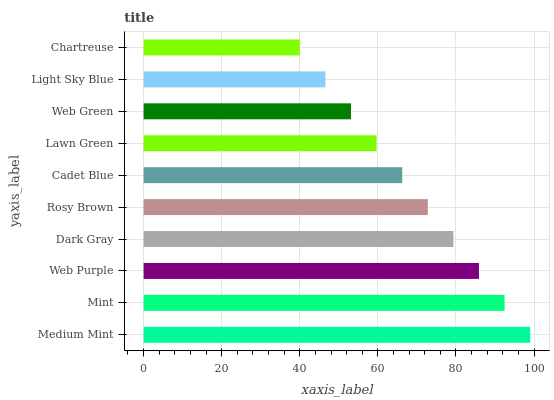Is Chartreuse the minimum?
Answer yes or no. Yes. Is Medium Mint the maximum?
Answer yes or no. Yes. Is Mint the minimum?
Answer yes or no. No. Is Mint the maximum?
Answer yes or no. No. Is Medium Mint greater than Mint?
Answer yes or no. Yes. Is Mint less than Medium Mint?
Answer yes or no. Yes. Is Mint greater than Medium Mint?
Answer yes or no. No. Is Medium Mint less than Mint?
Answer yes or no. No. Is Rosy Brown the high median?
Answer yes or no. Yes. Is Cadet Blue the low median?
Answer yes or no. Yes. Is Web Purple the high median?
Answer yes or no. No. Is Medium Mint the low median?
Answer yes or no. No. 